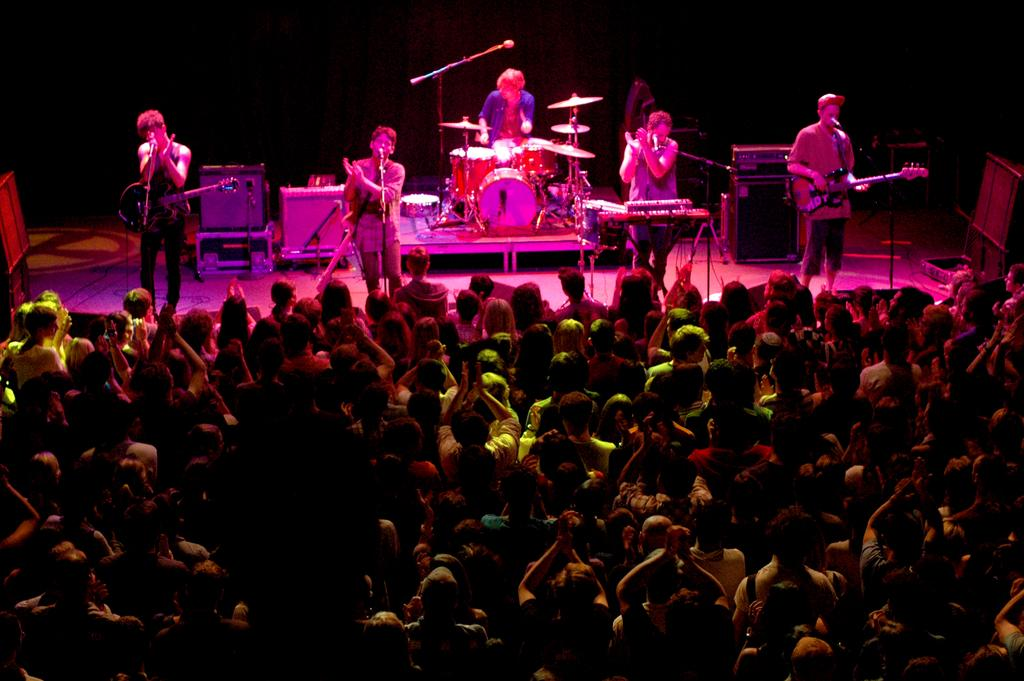How many people are in the image? There is a group of people in the image. Where are some of the people located in the image? Some people are on stage. What are the people on stage doing? The people on stage are playing musical instruments. What devices are present to amplify sound in the image? There are microphones and speakers in the image. What can be inferred about the lighting conditions in the image? The background of the image is dark. What religious beliefs are being discussed by the people on stage in the image? There is no indication of any religious discussion in the image; the people on stage are playing musical instruments. 